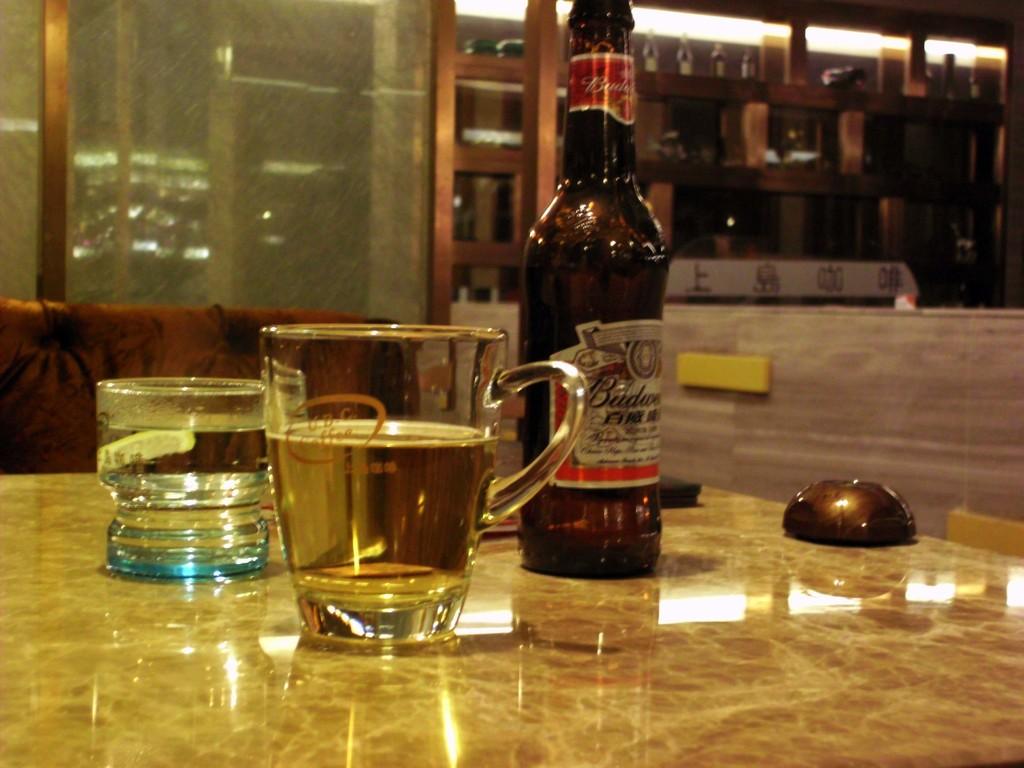Who makes this drink?
Your response must be concise. Budweiser. 